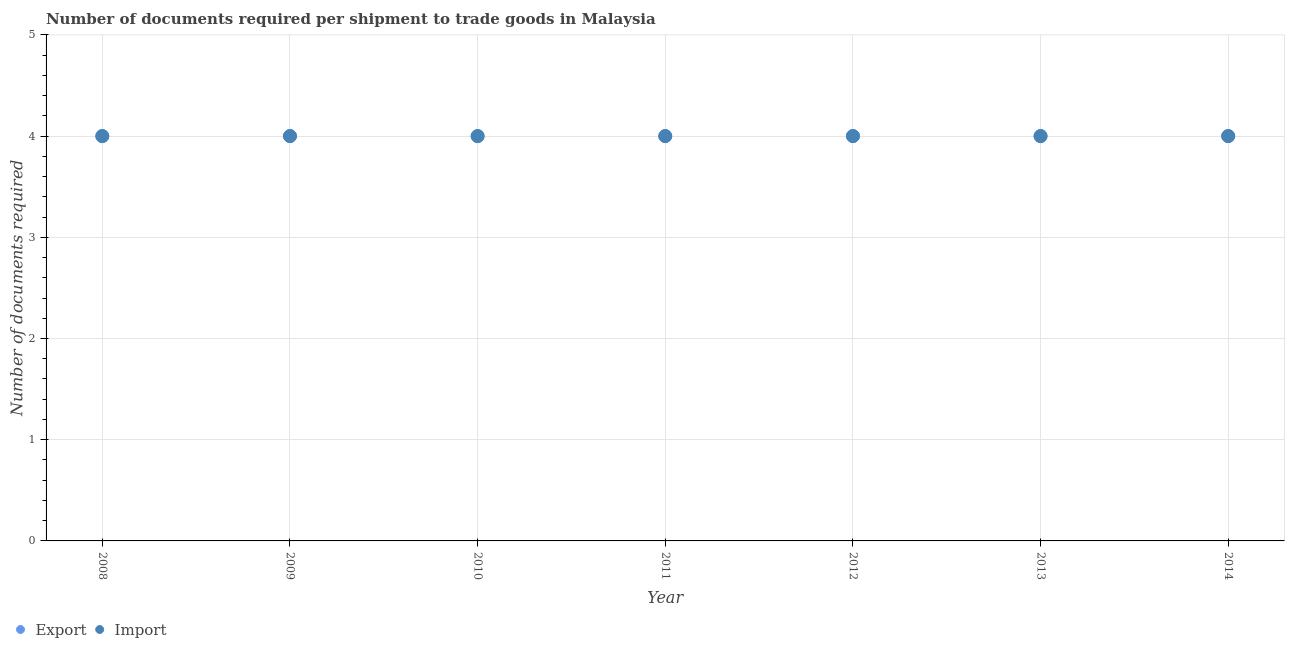What is the number of documents required to export goods in 2008?
Offer a terse response. 4. Across all years, what is the maximum number of documents required to export goods?
Make the answer very short. 4. Across all years, what is the minimum number of documents required to import goods?
Provide a succinct answer. 4. In which year was the number of documents required to import goods maximum?
Provide a short and direct response. 2008. In which year was the number of documents required to import goods minimum?
Make the answer very short. 2008. What is the total number of documents required to export goods in the graph?
Your answer should be compact. 28. What is the difference between the number of documents required to export goods in 2009 and that in 2011?
Keep it short and to the point. 0. What is the difference between the number of documents required to import goods in 2014 and the number of documents required to export goods in 2008?
Give a very brief answer. 0. In the year 2014, what is the difference between the number of documents required to export goods and number of documents required to import goods?
Keep it short and to the point. 0. In how many years, is the number of documents required to export goods greater than 2.2?
Offer a terse response. 7. Is the number of documents required to import goods in 2011 less than that in 2012?
Keep it short and to the point. No. In how many years, is the number of documents required to import goods greater than the average number of documents required to import goods taken over all years?
Your response must be concise. 0. Is the sum of the number of documents required to export goods in 2012 and 2013 greater than the maximum number of documents required to import goods across all years?
Provide a succinct answer. Yes. What is the title of the graph?
Your answer should be compact. Number of documents required per shipment to trade goods in Malaysia. What is the label or title of the X-axis?
Your response must be concise. Year. What is the label or title of the Y-axis?
Offer a very short reply. Number of documents required. What is the Number of documents required in Import in 2008?
Your response must be concise. 4. What is the Number of documents required in Export in 2009?
Make the answer very short. 4. What is the Number of documents required of Import in 2009?
Your answer should be compact. 4. What is the Number of documents required of Import in 2010?
Ensure brevity in your answer.  4. What is the Number of documents required in Export in 2012?
Keep it short and to the point. 4. What is the Number of documents required of Export in 2013?
Your answer should be compact. 4. What is the Number of documents required in Import in 2013?
Provide a succinct answer. 4. What is the Number of documents required in Export in 2014?
Give a very brief answer. 4. What is the Number of documents required of Import in 2014?
Offer a very short reply. 4. Across all years, what is the maximum Number of documents required of Import?
Make the answer very short. 4. What is the total Number of documents required of Export in the graph?
Your response must be concise. 28. What is the difference between the Number of documents required in Export in 2008 and that in 2009?
Offer a terse response. 0. What is the difference between the Number of documents required of Export in 2008 and that in 2010?
Your response must be concise. 0. What is the difference between the Number of documents required in Import in 2008 and that in 2010?
Provide a succinct answer. 0. What is the difference between the Number of documents required of Export in 2008 and that in 2011?
Provide a succinct answer. 0. What is the difference between the Number of documents required of Export in 2008 and that in 2012?
Provide a succinct answer. 0. What is the difference between the Number of documents required of Import in 2008 and that in 2013?
Your answer should be very brief. 0. What is the difference between the Number of documents required of Export in 2009 and that in 2010?
Provide a short and direct response. 0. What is the difference between the Number of documents required in Export in 2009 and that in 2011?
Provide a short and direct response. 0. What is the difference between the Number of documents required in Import in 2009 and that in 2011?
Offer a terse response. 0. What is the difference between the Number of documents required in Export in 2009 and that in 2012?
Give a very brief answer. 0. What is the difference between the Number of documents required in Export in 2009 and that in 2013?
Your answer should be compact. 0. What is the difference between the Number of documents required in Import in 2009 and that in 2013?
Keep it short and to the point. 0. What is the difference between the Number of documents required of Export in 2010 and that in 2011?
Make the answer very short. 0. What is the difference between the Number of documents required in Export in 2010 and that in 2012?
Offer a terse response. 0. What is the difference between the Number of documents required in Export in 2010 and that in 2014?
Your answer should be compact. 0. What is the difference between the Number of documents required in Import in 2010 and that in 2014?
Keep it short and to the point. 0. What is the difference between the Number of documents required of Export in 2011 and that in 2012?
Your answer should be compact. 0. What is the difference between the Number of documents required in Import in 2011 and that in 2012?
Provide a short and direct response. 0. What is the difference between the Number of documents required of Export in 2011 and that in 2013?
Keep it short and to the point. 0. What is the difference between the Number of documents required of Import in 2011 and that in 2013?
Your answer should be compact. 0. What is the difference between the Number of documents required of Export in 2011 and that in 2014?
Your answer should be very brief. 0. What is the difference between the Number of documents required in Import in 2012 and that in 2013?
Give a very brief answer. 0. What is the difference between the Number of documents required in Import in 2012 and that in 2014?
Your response must be concise. 0. What is the difference between the Number of documents required in Export in 2013 and that in 2014?
Give a very brief answer. 0. What is the difference between the Number of documents required in Export in 2008 and the Number of documents required in Import in 2009?
Give a very brief answer. 0. What is the difference between the Number of documents required in Export in 2008 and the Number of documents required in Import in 2010?
Ensure brevity in your answer.  0. What is the difference between the Number of documents required in Export in 2008 and the Number of documents required in Import in 2012?
Your response must be concise. 0. What is the difference between the Number of documents required of Export in 2008 and the Number of documents required of Import in 2014?
Ensure brevity in your answer.  0. What is the difference between the Number of documents required in Export in 2009 and the Number of documents required in Import in 2011?
Give a very brief answer. 0. What is the difference between the Number of documents required in Export in 2009 and the Number of documents required in Import in 2012?
Offer a very short reply. 0. What is the difference between the Number of documents required of Export in 2009 and the Number of documents required of Import in 2013?
Provide a succinct answer. 0. What is the difference between the Number of documents required in Export in 2009 and the Number of documents required in Import in 2014?
Make the answer very short. 0. What is the difference between the Number of documents required of Export in 2010 and the Number of documents required of Import in 2012?
Provide a succinct answer. 0. What is the difference between the Number of documents required in Export in 2010 and the Number of documents required in Import in 2013?
Give a very brief answer. 0. What is the difference between the Number of documents required in Export in 2011 and the Number of documents required in Import in 2012?
Provide a short and direct response. 0. What is the difference between the Number of documents required of Export in 2011 and the Number of documents required of Import in 2013?
Provide a short and direct response. 0. What is the difference between the Number of documents required in Export in 2012 and the Number of documents required in Import in 2014?
Your answer should be compact. 0. What is the difference between the Number of documents required in Export in 2013 and the Number of documents required in Import in 2014?
Offer a terse response. 0. What is the average Number of documents required in Export per year?
Keep it short and to the point. 4. In the year 2008, what is the difference between the Number of documents required of Export and Number of documents required of Import?
Ensure brevity in your answer.  0. In the year 2009, what is the difference between the Number of documents required of Export and Number of documents required of Import?
Make the answer very short. 0. In the year 2010, what is the difference between the Number of documents required in Export and Number of documents required in Import?
Offer a very short reply. 0. In the year 2012, what is the difference between the Number of documents required of Export and Number of documents required of Import?
Ensure brevity in your answer.  0. In the year 2013, what is the difference between the Number of documents required of Export and Number of documents required of Import?
Offer a terse response. 0. What is the ratio of the Number of documents required in Import in 2008 to that in 2009?
Make the answer very short. 1. What is the ratio of the Number of documents required in Export in 2008 to that in 2011?
Give a very brief answer. 1. What is the ratio of the Number of documents required in Export in 2008 to that in 2012?
Provide a succinct answer. 1. What is the ratio of the Number of documents required of Export in 2008 to that in 2013?
Offer a terse response. 1. What is the ratio of the Number of documents required of Export in 2008 to that in 2014?
Make the answer very short. 1. What is the ratio of the Number of documents required in Export in 2009 to that in 2010?
Give a very brief answer. 1. What is the ratio of the Number of documents required in Export in 2009 to that in 2011?
Your answer should be very brief. 1. What is the ratio of the Number of documents required of Import in 2009 to that in 2012?
Your answer should be compact. 1. What is the ratio of the Number of documents required in Import in 2009 to that in 2013?
Your answer should be compact. 1. What is the ratio of the Number of documents required of Export in 2009 to that in 2014?
Offer a terse response. 1. What is the ratio of the Number of documents required of Import in 2009 to that in 2014?
Make the answer very short. 1. What is the ratio of the Number of documents required in Export in 2010 to that in 2011?
Your answer should be compact. 1. What is the ratio of the Number of documents required of Import in 2010 to that in 2012?
Your answer should be very brief. 1. What is the ratio of the Number of documents required in Import in 2010 to that in 2013?
Keep it short and to the point. 1. What is the ratio of the Number of documents required of Export in 2010 to that in 2014?
Offer a very short reply. 1. What is the ratio of the Number of documents required of Import in 2010 to that in 2014?
Offer a very short reply. 1. What is the ratio of the Number of documents required in Export in 2011 to that in 2012?
Keep it short and to the point. 1. What is the ratio of the Number of documents required in Import in 2011 to that in 2014?
Your answer should be compact. 1. What is the ratio of the Number of documents required of Export in 2012 to that in 2013?
Offer a very short reply. 1. What is the ratio of the Number of documents required in Export in 2012 to that in 2014?
Your response must be concise. 1. What is the ratio of the Number of documents required in Import in 2013 to that in 2014?
Offer a very short reply. 1. What is the difference between the highest and the second highest Number of documents required of Export?
Provide a short and direct response. 0. What is the difference between the highest and the second highest Number of documents required of Import?
Keep it short and to the point. 0. 